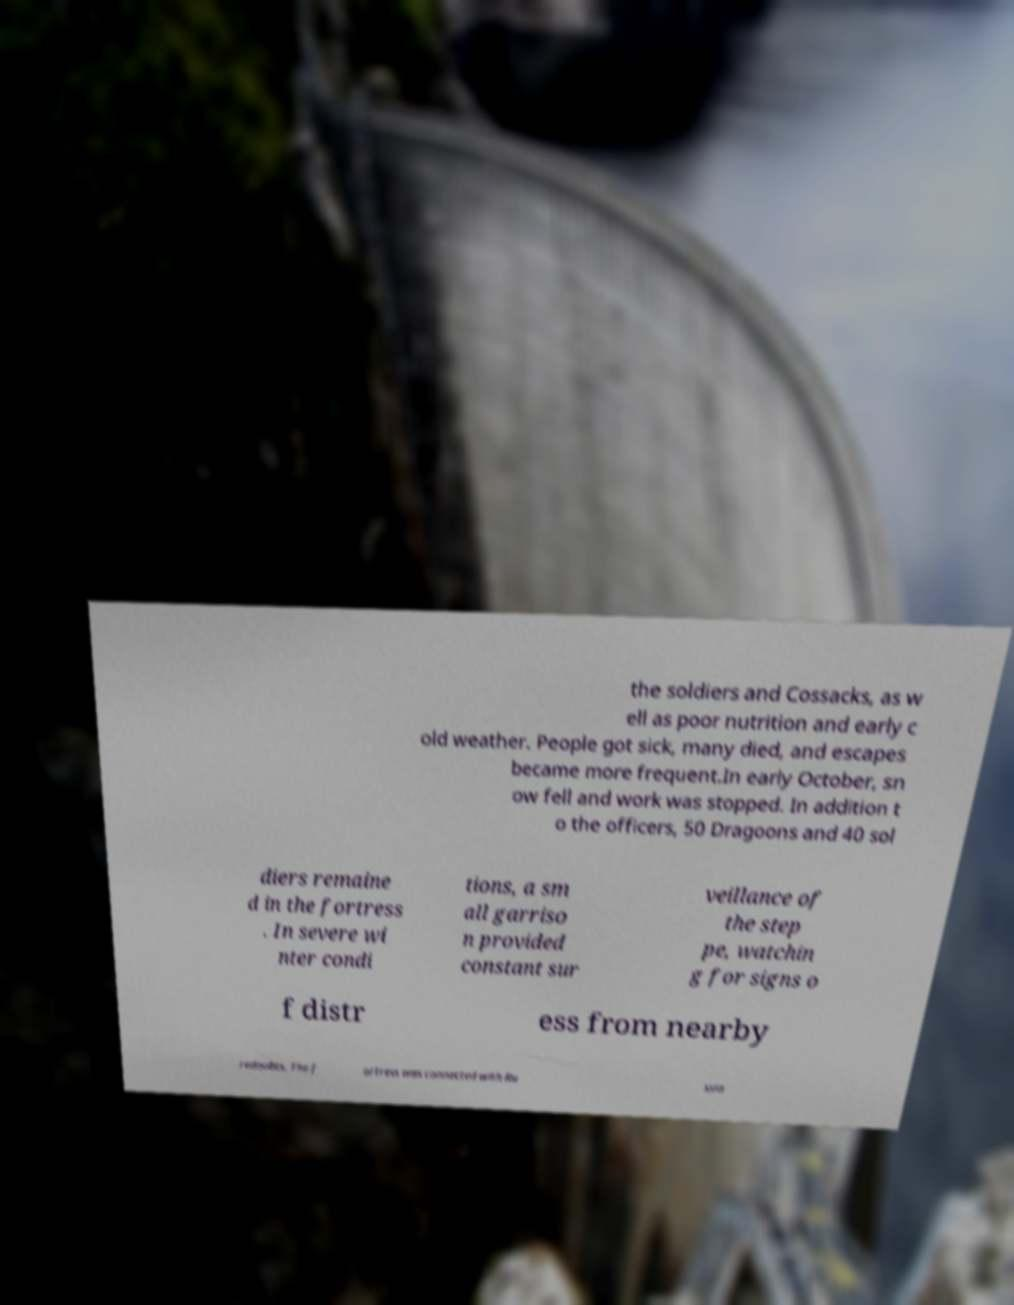There's text embedded in this image that I need extracted. Can you transcribe it verbatim? the soldiers and Cossacks, as w ell as poor nutrition and early c old weather. People got sick, many died, and escapes became more frequent.In early October, sn ow fell and work was stopped. In addition t o the officers, 50 Dragoons and 40 sol diers remaine d in the fortress . In severe wi nter condi tions, a sm all garriso n provided constant sur veillance of the step pe, watchin g for signs o f distr ess from nearby redoubts. The f ortress was connected with Ru ssia 